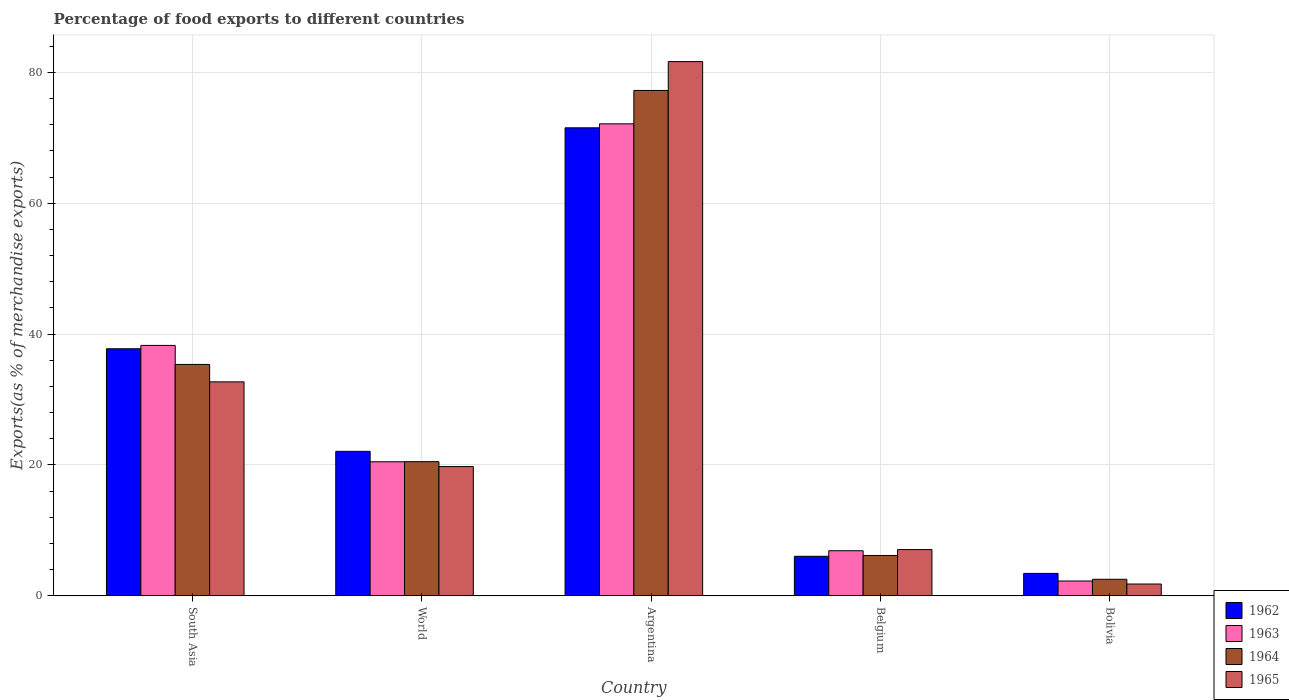How many different coloured bars are there?
Keep it short and to the point. 4. Are the number of bars per tick equal to the number of legend labels?
Ensure brevity in your answer.  Yes. How many bars are there on the 2nd tick from the left?
Your response must be concise. 4. What is the percentage of exports to different countries in 1964 in Argentina?
Your response must be concise. 77.23. Across all countries, what is the maximum percentage of exports to different countries in 1963?
Provide a succinct answer. 72.12. Across all countries, what is the minimum percentage of exports to different countries in 1962?
Your answer should be very brief. 3.43. In which country was the percentage of exports to different countries in 1962 maximum?
Give a very brief answer. Argentina. In which country was the percentage of exports to different countries in 1964 minimum?
Your answer should be very brief. Bolivia. What is the total percentage of exports to different countries in 1964 in the graph?
Ensure brevity in your answer.  141.79. What is the difference between the percentage of exports to different countries in 1962 in Argentina and that in South Asia?
Provide a short and direct response. 33.76. What is the difference between the percentage of exports to different countries in 1965 in Bolivia and the percentage of exports to different countries in 1963 in South Asia?
Ensure brevity in your answer.  -36.46. What is the average percentage of exports to different countries in 1964 per country?
Provide a short and direct response. 28.36. What is the difference between the percentage of exports to different countries of/in 1965 and percentage of exports to different countries of/in 1962 in Argentina?
Ensure brevity in your answer.  10.12. In how many countries, is the percentage of exports to different countries in 1965 greater than 52 %?
Your answer should be compact. 1. What is the ratio of the percentage of exports to different countries in 1964 in Argentina to that in South Asia?
Provide a short and direct response. 2.18. Is the percentage of exports to different countries in 1965 in Belgium less than that in Bolivia?
Make the answer very short. No. Is the difference between the percentage of exports to different countries in 1965 in Belgium and Bolivia greater than the difference between the percentage of exports to different countries in 1962 in Belgium and Bolivia?
Make the answer very short. Yes. What is the difference between the highest and the second highest percentage of exports to different countries in 1962?
Your answer should be very brief. 15.67. What is the difference between the highest and the lowest percentage of exports to different countries in 1965?
Offer a terse response. 79.83. In how many countries, is the percentage of exports to different countries in 1963 greater than the average percentage of exports to different countries in 1963 taken over all countries?
Provide a succinct answer. 2. What does the 4th bar from the left in South Asia represents?
Offer a very short reply. 1965. What does the 1st bar from the right in Argentina represents?
Ensure brevity in your answer.  1965. Is it the case that in every country, the sum of the percentage of exports to different countries in 1963 and percentage of exports to different countries in 1962 is greater than the percentage of exports to different countries in 1964?
Offer a terse response. Yes. What is the difference between two consecutive major ticks on the Y-axis?
Give a very brief answer. 20. Does the graph contain any zero values?
Your answer should be very brief. No. Does the graph contain grids?
Give a very brief answer. Yes. How many legend labels are there?
Your answer should be compact. 4. What is the title of the graph?
Give a very brief answer. Percentage of food exports to different countries. What is the label or title of the Y-axis?
Your answer should be very brief. Exports(as % of merchandise exports). What is the Exports(as % of merchandise exports) of 1962 in South Asia?
Give a very brief answer. 37.75. What is the Exports(as % of merchandise exports) of 1963 in South Asia?
Offer a very short reply. 38.26. What is the Exports(as % of merchandise exports) in 1964 in South Asia?
Your answer should be very brief. 35.36. What is the Exports(as % of merchandise exports) of 1965 in South Asia?
Keep it short and to the point. 32.7. What is the Exports(as % of merchandise exports) in 1962 in World?
Give a very brief answer. 22.08. What is the Exports(as % of merchandise exports) of 1963 in World?
Make the answer very short. 20.49. What is the Exports(as % of merchandise exports) of 1964 in World?
Offer a terse response. 20.5. What is the Exports(as % of merchandise exports) of 1965 in World?
Provide a short and direct response. 19.75. What is the Exports(as % of merchandise exports) of 1962 in Argentina?
Give a very brief answer. 71.52. What is the Exports(as % of merchandise exports) in 1963 in Argentina?
Provide a succinct answer. 72.12. What is the Exports(as % of merchandise exports) of 1964 in Argentina?
Your response must be concise. 77.23. What is the Exports(as % of merchandise exports) of 1965 in Argentina?
Your answer should be compact. 81.64. What is the Exports(as % of merchandise exports) of 1962 in Belgium?
Offer a terse response. 6.04. What is the Exports(as % of merchandise exports) of 1963 in Belgium?
Give a very brief answer. 6.89. What is the Exports(as % of merchandise exports) in 1964 in Belgium?
Provide a short and direct response. 6.17. What is the Exports(as % of merchandise exports) in 1965 in Belgium?
Ensure brevity in your answer.  7.07. What is the Exports(as % of merchandise exports) of 1962 in Bolivia?
Keep it short and to the point. 3.43. What is the Exports(as % of merchandise exports) of 1963 in Bolivia?
Offer a terse response. 2.27. What is the Exports(as % of merchandise exports) of 1964 in Bolivia?
Make the answer very short. 2.53. What is the Exports(as % of merchandise exports) in 1965 in Bolivia?
Provide a short and direct response. 1.81. Across all countries, what is the maximum Exports(as % of merchandise exports) in 1962?
Your answer should be compact. 71.52. Across all countries, what is the maximum Exports(as % of merchandise exports) in 1963?
Provide a short and direct response. 72.12. Across all countries, what is the maximum Exports(as % of merchandise exports) of 1964?
Keep it short and to the point. 77.23. Across all countries, what is the maximum Exports(as % of merchandise exports) of 1965?
Ensure brevity in your answer.  81.64. Across all countries, what is the minimum Exports(as % of merchandise exports) of 1962?
Offer a very short reply. 3.43. Across all countries, what is the minimum Exports(as % of merchandise exports) of 1963?
Make the answer very short. 2.27. Across all countries, what is the minimum Exports(as % of merchandise exports) of 1964?
Provide a short and direct response. 2.53. Across all countries, what is the minimum Exports(as % of merchandise exports) in 1965?
Ensure brevity in your answer.  1.81. What is the total Exports(as % of merchandise exports) of 1962 in the graph?
Your response must be concise. 140.82. What is the total Exports(as % of merchandise exports) in 1963 in the graph?
Your answer should be compact. 140.03. What is the total Exports(as % of merchandise exports) in 1964 in the graph?
Make the answer very short. 141.79. What is the total Exports(as % of merchandise exports) in 1965 in the graph?
Make the answer very short. 142.96. What is the difference between the Exports(as % of merchandise exports) of 1962 in South Asia and that in World?
Provide a short and direct response. 15.67. What is the difference between the Exports(as % of merchandise exports) in 1963 in South Asia and that in World?
Give a very brief answer. 17.78. What is the difference between the Exports(as % of merchandise exports) of 1964 in South Asia and that in World?
Offer a very short reply. 14.86. What is the difference between the Exports(as % of merchandise exports) of 1965 in South Asia and that in World?
Offer a very short reply. 12.95. What is the difference between the Exports(as % of merchandise exports) of 1962 in South Asia and that in Argentina?
Provide a succinct answer. -33.76. What is the difference between the Exports(as % of merchandise exports) in 1963 in South Asia and that in Argentina?
Your answer should be compact. -33.86. What is the difference between the Exports(as % of merchandise exports) in 1964 in South Asia and that in Argentina?
Your response must be concise. -41.87. What is the difference between the Exports(as % of merchandise exports) of 1965 in South Asia and that in Argentina?
Give a very brief answer. -48.94. What is the difference between the Exports(as % of merchandise exports) of 1962 in South Asia and that in Belgium?
Give a very brief answer. 31.71. What is the difference between the Exports(as % of merchandise exports) of 1963 in South Asia and that in Belgium?
Keep it short and to the point. 31.37. What is the difference between the Exports(as % of merchandise exports) in 1964 in South Asia and that in Belgium?
Provide a short and direct response. 29.19. What is the difference between the Exports(as % of merchandise exports) of 1965 in South Asia and that in Belgium?
Keep it short and to the point. 25.62. What is the difference between the Exports(as % of merchandise exports) of 1962 in South Asia and that in Bolivia?
Ensure brevity in your answer.  34.32. What is the difference between the Exports(as % of merchandise exports) of 1963 in South Asia and that in Bolivia?
Offer a very short reply. 36. What is the difference between the Exports(as % of merchandise exports) of 1964 in South Asia and that in Bolivia?
Give a very brief answer. 32.83. What is the difference between the Exports(as % of merchandise exports) in 1965 in South Asia and that in Bolivia?
Keep it short and to the point. 30.89. What is the difference between the Exports(as % of merchandise exports) of 1962 in World and that in Argentina?
Your answer should be compact. -49.44. What is the difference between the Exports(as % of merchandise exports) of 1963 in World and that in Argentina?
Give a very brief answer. -51.64. What is the difference between the Exports(as % of merchandise exports) in 1964 in World and that in Argentina?
Make the answer very short. -56.72. What is the difference between the Exports(as % of merchandise exports) in 1965 in World and that in Argentina?
Give a very brief answer. -61.88. What is the difference between the Exports(as % of merchandise exports) in 1962 in World and that in Belgium?
Offer a terse response. 16.04. What is the difference between the Exports(as % of merchandise exports) in 1963 in World and that in Belgium?
Provide a short and direct response. 13.6. What is the difference between the Exports(as % of merchandise exports) of 1964 in World and that in Belgium?
Provide a short and direct response. 14.33. What is the difference between the Exports(as % of merchandise exports) in 1965 in World and that in Belgium?
Keep it short and to the point. 12.68. What is the difference between the Exports(as % of merchandise exports) in 1962 in World and that in Bolivia?
Your answer should be very brief. 18.65. What is the difference between the Exports(as % of merchandise exports) in 1963 in World and that in Bolivia?
Provide a succinct answer. 18.22. What is the difference between the Exports(as % of merchandise exports) in 1964 in World and that in Bolivia?
Offer a terse response. 17.97. What is the difference between the Exports(as % of merchandise exports) of 1965 in World and that in Bolivia?
Provide a succinct answer. 17.94. What is the difference between the Exports(as % of merchandise exports) of 1962 in Argentina and that in Belgium?
Your answer should be compact. 65.47. What is the difference between the Exports(as % of merchandise exports) of 1963 in Argentina and that in Belgium?
Provide a short and direct response. 65.23. What is the difference between the Exports(as % of merchandise exports) in 1964 in Argentina and that in Belgium?
Provide a short and direct response. 71.06. What is the difference between the Exports(as % of merchandise exports) of 1965 in Argentina and that in Belgium?
Keep it short and to the point. 74.56. What is the difference between the Exports(as % of merchandise exports) of 1962 in Argentina and that in Bolivia?
Provide a short and direct response. 68.09. What is the difference between the Exports(as % of merchandise exports) in 1963 in Argentina and that in Bolivia?
Make the answer very short. 69.86. What is the difference between the Exports(as % of merchandise exports) in 1964 in Argentina and that in Bolivia?
Keep it short and to the point. 74.69. What is the difference between the Exports(as % of merchandise exports) of 1965 in Argentina and that in Bolivia?
Provide a short and direct response. 79.83. What is the difference between the Exports(as % of merchandise exports) of 1962 in Belgium and that in Bolivia?
Your answer should be compact. 2.61. What is the difference between the Exports(as % of merchandise exports) in 1963 in Belgium and that in Bolivia?
Make the answer very short. 4.62. What is the difference between the Exports(as % of merchandise exports) in 1964 in Belgium and that in Bolivia?
Your response must be concise. 3.64. What is the difference between the Exports(as % of merchandise exports) of 1965 in Belgium and that in Bolivia?
Ensure brevity in your answer.  5.27. What is the difference between the Exports(as % of merchandise exports) in 1962 in South Asia and the Exports(as % of merchandise exports) in 1963 in World?
Your answer should be compact. 17.27. What is the difference between the Exports(as % of merchandise exports) of 1962 in South Asia and the Exports(as % of merchandise exports) of 1964 in World?
Your answer should be very brief. 17.25. What is the difference between the Exports(as % of merchandise exports) in 1962 in South Asia and the Exports(as % of merchandise exports) in 1965 in World?
Your answer should be compact. 18. What is the difference between the Exports(as % of merchandise exports) of 1963 in South Asia and the Exports(as % of merchandise exports) of 1964 in World?
Keep it short and to the point. 17.76. What is the difference between the Exports(as % of merchandise exports) in 1963 in South Asia and the Exports(as % of merchandise exports) in 1965 in World?
Offer a very short reply. 18.51. What is the difference between the Exports(as % of merchandise exports) in 1964 in South Asia and the Exports(as % of merchandise exports) in 1965 in World?
Give a very brief answer. 15.61. What is the difference between the Exports(as % of merchandise exports) in 1962 in South Asia and the Exports(as % of merchandise exports) in 1963 in Argentina?
Give a very brief answer. -34.37. What is the difference between the Exports(as % of merchandise exports) in 1962 in South Asia and the Exports(as % of merchandise exports) in 1964 in Argentina?
Your response must be concise. -39.47. What is the difference between the Exports(as % of merchandise exports) in 1962 in South Asia and the Exports(as % of merchandise exports) in 1965 in Argentina?
Offer a very short reply. -43.88. What is the difference between the Exports(as % of merchandise exports) in 1963 in South Asia and the Exports(as % of merchandise exports) in 1964 in Argentina?
Give a very brief answer. -38.96. What is the difference between the Exports(as % of merchandise exports) of 1963 in South Asia and the Exports(as % of merchandise exports) of 1965 in Argentina?
Provide a short and direct response. -43.37. What is the difference between the Exports(as % of merchandise exports) in 1964 in South Asia and the Exports(as % of merchandise exports) in 1965 in Argentina?
Your answer should be compact. -46.28. What is the difference between the Exports(as % of merchandise exports) in 1962 in South Asia and the Exports(as % of merchandise exports) in 1963 in Belgium?
Make the answer very short. 30.86. What is the difference between the Exports(as % of merchandise exports) in 1962 in South Asia and the Exports(as % of merchandise exports) in 1964 in Belgium?
Your response must be concise. 31.58. What is the difference between the Exports(as % of merchandise exports) of 1962 in South Asia and the Exports(as % of merchandise exports) of 1965 in Belgium?
Offer a terse response. 30.68. What is the difference between the Exports(as % of merchandise exports) of 1963 in South Asia and the Exports(as % of merchandise exports) of 1964 in Belgium?
Your answer should be compact. 32.09. What is the difference between the Exports(as % of merchandise exports) of 1963 in South Asia and the Exports(as % of merchandise exports) of 1965 in Belgium?
Your response must be concise. 31.19. What is the difference between the Exports(as % of merchandise exports) of 1964 in South Asia and the Exports(as % of merchandise exports) of 1965 in Belgium?
Ensure brevity in your answer.  28.29. What is the difference between the Exports(as % of merchandise exports) in 1962 in South Asia and the Exports(as % of merchandise exports) in 1963 in Bolivia?
Give a very brief answer. 35.49. What is the difference between the Exports(as % of merchandise exports) of 1962 in South Asia and the Exports(as % of merchandise exports) of 1964 in Bolivia?
Provide a short and direct response. 35.22. What is the difference between the Exports(as % of merchandise exports) of 1962 in South Asia and the Exports(as % of merchandise exports) of 1965 in Bolivia?
Your answer should be compact. 35.95. What is the difference between the Exports(as % of merchandise exports) of 1963 in South Asia and the Exports(as % of merchandise exports) of 1964 in Bolivia?
Ensure brevity in your answer.  35.73. What is the difference between the Exports(as % of merchandise exports) of 1963 in South Asia and the Exports(as % of merchandise exports) of 1965 in Bolivia?
Provide a short and direct response. 36.46. What is the difference between the Exports(as % of merchandise exports) of 1964 in South Asia and the Exports(as % of merchandise exports) of 1965 in Bolivia?
Provide a succinct answer. 33.55. What is the difference between the Exports(as % of merchandise exports) in 1962 in World and the Exports(as % of merchandise exports) in 1963 in Argentina?
Provide a succinct answer. -50.04. What is the difference between the Exports(as % of merchandise exports) of 1962 in World and the Exports(as % of merchandise exports) of 1964 in Argentina?
Your answer should be compact. -55.15. What is the difference between the Exports(as % of merchandise exports) of 1962 in World and the Exports(as % of merchandise exports) of 1965 in Argentina?
Your answer should be compact. -59.55. What is the difference between the Exports(as % of merchandise exports) of 1963 in World and the Exports(as % of merchandise exports) of 1964 in Argentina?
Keep it short and to the point. -56.74. What is the difference between the Exports(as % of merchandise exports) of 1963 in World and the Exports(as % of merchandise exports) of 1965 in Argentina?
Provide a short and direct response. -61.15. What is the difference between the Exports(as % of merchandise exports) of 1964 in World and the Exports(as % of merchandise exports) of 1965 in Argentina?
Make the answer very short. -61.13. What is the difference between the Exports(as % of merchandise exports) in 1962 in World and the Exports(as % of merchandise exports) in 1963 in Belgium?
Keep it short and to the point. 15.19. What is the difference between the Exports(as % of merchandise exports) of 1962 in World and the Exports(as % of merchandise exports) of 1964 in Belgium?
Give a very brief answer. 15.91. What is the difference between the Exports(as % of merchandise exports) of 1962 in World and the Exports(as % of merchandise exports) of 1965 in Belgium?
Ensure brevity in your answer.  15.01. What is the difference between the Exports(as % of merchandise exports) of 1963 in World and the Exports(as % of merchandise exports) of 1964 in Belgium?
Provide a succinct answer. 14.32. What is the difference between the Exports(as % of merchandise exports) of 1963 in World and the Exports(as % of merchandise exports) of 1965 in Belgium?
Keep it short and to the point. 13.41. What is the difference between the Exports(as % of merchandise exports) in 1964 in World and the Exports(as % of merchandise exports) in 1965 in Belgium?
Give a very brief answer. 13.43. What is the difference between the Exports(as % of merchandise exports) in 1962 in World and the Exports(as % of merchandise exports) in 1963 in Bolivia?
Keep it short and to the point. 19.81. What is the difference between the Exports(as % of merchandise exports) in 1962 in World and the Exports(as % of merchandise exports) in 1964 in Bolivia?
Provide a succinct answer. 19.55. What is the difference between the Exports(as % of merchandise exports) in 1962 in World and the Exports(as % of merchandise exports) in 1965 in Bolivia?
Make the answer very short. 20.27. What is the difference between the Exports(as % of merchandise exports) in 1963 in World and the Exports(as % of merchandise exports) in 1964 in Bolivia?
Your response must be concise. 17.95. What is the difference between the Exports(as % of merchandise exports) of 1963 in World and the Exports(as % of merchandise exports) of 1965 in Bolivia?
Provide a succinct answer. 18.68. What is the difference between the Exports(as % of merchandise exports) in 1964 in World and the Exports(as % of merchandise exports) in 1965 in Bolivia?
Your response must be concise. 18.7. What is the difference between the Exports(as % of merchandise exports) of 1962 in Argentina and the Exports(as % of merchandise exports) of 1963 in Belgium?
Ensure brevity in your answer.  64.63. What is the difference between the Exports(as % of merchandise exports) in 1962 in Argentina and the Exports(as % of merchandise exports) in 1964 in Belgium?
Give a very brief answer. 65.35. What is the difference between the Exports(as % of merchandise exports) in 1962 in Argentina and the Exports(as % of merchandise exports) in 1965 in Belgium?
Offer a very short reply. 64.44. What is the difference between the Exports(as % of merchandise exports) of 1963 in Argentina and the Exports(as % of merchandise exports) of 1964 in Belgium?
Give a very brief answer. 65.95. What is the difference between the Exports(as % of merchandise exports) in 1963 in Argentina and the Exports(as % of merchandise exports) in 1965 in Belgium?
Give a very brief answer. 65.05. What is the difference between the Exports(as % of merchandise exports) in 1964 in Argentina and the Exports(as % of merchandise exports) in 1965 in Belgium?
Offer a very short reply. 70.15. What is the difference between the Exports(as % of merchandise exports) of 1962 in Argentina and the Exports(as % of merchandise exports) of 1963 in Bolivia?
Provide a short and direct response. 69.25. What is the difference between the Exports(as % of merchandise exports) in 1962 in Argentina and the Exports(as % of merchandise exports) in 1964 in Bolivia?
Your answer should be very brief. 68.98. What is the difference between the Exports(as % of merchandise exports) of 1962 in Argentina and the Exports(as % of merchandise exports) of 1965 in Bolivia?
Offer a terse response. 69.71. What is the difference between the Exports(as % of merchandise exports) of 1963 in Argentina and the Exports(as % of merchandise exports) of 1964 in Bolivia?
Ensure brevity in your answer.  69.59. What is the difference between the Exports(as % of merchandise exports) of 1963 in Argentina and the Exports(as % of merchandise exports) of 1965 in Bolivia?
Provide a short and direct response. 70.32. What is the difference between the Exports(as % of merchandise exports) of 1964 in Argentina and the Exports(as % of merchandise exports) of 1965 in Bolivia?
Your response must be concise. 75.42. What is the difference between the Exports(as % of merchandise exports) of 1962 in Belgium and the Exports(as % of merchandise exports) of 1963 in Bolivia?
Your response must be concise. 3.78. What is the difference between the Exports(as % of merchandise exports) of 1962 in Belgium and the Exports(as % of merchandise exports) of 1964 in Bolivia?
Ensure brevity in your answer.  3.51. What is the difference between the Exports(as % of merchandise exports) of 1962 in Belgium and the Exports(as % of merchandise exports) of 1965 in Bolivia?
Offer a very short reply. 4.24. What is the difference between the Exports(as % of merchandise exports) of 1963 in Belgium and the Exports(as % of merchandise exports) of 1964 in Bolivia?
Provide a succinct answer. 4.36. What is the difference between the Exports(as % of merchandise exports) of 1963 in Belgium and the Exports(as % of merchandise exports) of 1965 in Bolivia?
Your answer should be compact. 5.08. What is the difference between the Exports(as % of merchandise exports) in 1964 in Belgium and the Exports(as % of merchandise exports) in 1965 in Bolivia?
Make the answer very short. 4.36. What is the average Exports(as % of merchandise exports) of 1962 per country?
Your response must be concise. 28.16. What is the average Exports(as % of merchandise exports) in 1963 per country?
Your answer should be compact. 28.01. What is the average Exports(as % of merchandise exports) in 1964 per country?
Ensure brevity in your answer.  28.36. What is the average Exports(as % of merchandise exports) in 1965 per country?
Offer a terse response. 28.59. What is the difference between the Exports(as % of merchandise exports) in 1962 and Exports(as % of merchandise exports) in 1963 in South Asia?
Provide a succinct answer. -0.51. What is the difference between the Exports(as % of merchandise exports) of 1962 and Exports(as % of merchandise exports) of 1964 in South Asia?
Your answer should be compact. 2.39. What is the difference between the Exports(as % of merchandise exports) in 1962 and Exports(as % of merchandise exports) in 1965 in South Asia?
Offer a terse response. 5.06. What is the difference between the Exports(as % of merchandise exports) of 1963 and Exports(as % of merchandise exports) of 1964 in South Asia?
Provide a short and direct response. 2.9. What is the difference between the Exports(as % of merchandise exports) in 1963 and Exports(as % of merchandise exports) in 1965 in South Asia?
Your answer should be compact. 5.57. What is the difference between the Exports(as % of merchandise exports) of 1964 and Exports(as % of merchandise exports) of 1965 in South Asia?
Ensure brevity in your answer.  2.66. What is the difference between the Exports(as % of merchandise exports) in 1962 and Exports(as % of merchandise exports) in 1963 in World?
Keep it short and to the point. 1.59. What is the difference between the Exports(as % of merchandise exports) of 1962 and Exports(as % of merchandise exports) of 1964 in World?
Provide a succinct answer. 1.58. What is the difference between the Exports(as % of merchandise exports) in 1962 and Exports(as % of merchandise exports) in 1965 in World?
Your answer should be very brief. 2.33. What is the difference between the Exports(as % of merchandise exports) of 1963 and Exports(as % of merchandise exports) of 1964 in World?
Provide a short and direct response. -0.02. What is the difference between the Exports(as % of merchandise exports) of 1963 and Exports(as % of merchandise exports) of 1965 in World?
Provide a short and direct response. 0.74. What is the difference between the Exports(as % of merchandise exports) of 1964 and Exports(as % of merchandise exports) of 1965 in World?
Provide a short and direct response. 0.75. What is the difference between the Exports(as % of merchandise exports) in 1962 and Exports(as % of merchandise exports) in 1963 in Argentina?
Your answer should be compact. -0.61. What is the difference between the Exports(as % of merchandise exports) of 1962 and Exports(as % of merchandise exports) of 1964 in Argentina?
Provide a short and direct response. -5.71. What is the difference between the Exports(as % of merchandise exports) of 1962 and Exports(as % of merchandise exports) of 1965 in Argentina?
Provide a short and direct response. -10.12. What is the difference between the Exports(as % of merchandise exports) in 1963 and Exports(as % of merchandise exports) in 1964 in Argentina?
Give a very brief answer. -5.1. What is the difference between the Exports(as % of merchandise exports) in 1963 and Exports(as % of merchandise exports) in 1965 in Argentina?
Keep it short and to the point. -9.51. What is the difference between the Exports(as % of merchandise exports) of 1964 and Exports(as % of merchandise exports) of 1965 in Argentina?
Offer a terse response. -4.41. What is the difference between the Exports(as % of merchandise exports) of 1962 and Exports(as % of merchandise exports) of 1963 in Belgium?
Provide a short and direct response. -0.85. What is the difference between the Exports(as % of merchandise exports) in 1962 and Exports(as % of merchandise exports) in 1964 in Belgium?
Offer a terse response. -0.13. What is the difference between the Exports(as % of merchandise exports) of 1962 and Exports(as % of merchandise exports) of 1965 in Belgium?
Offer a terse response. -1.03. What is the difference between the Exports(as % of merchandise exports) in 1963 and Exports(as % of merchandise exports) in 1964 in Belgium?
Keep it short and to the point. 0.72. What is the difference between the Exports(as % of merchandise exports) in 1963 and Exports(as % of merchandise exports) in 1965 in Belgium?
Provide a short and direct response. -0.18. What is the difference between the Exports(as % of merchandise exports) in 1964 and Exports(as % of merchandise exports) in 1965 in Belgium?
Ensure brevity in your answer.  -0.9. What is the difference between the Exports(as % of merchandise exports) of 1962 and Exports(as % of merchandise exports) of 1963 in Bolivia?
Provide a succinct answer. 1.16. What is the difference between the Exports(as % of merchandise exports) of 1962 and Exports(as % of merchandise exports) of 1964 in Bolivia?
Your response must be concise. 0.9. What is the difference between the Exports(as % of merchandise exports) in 1962 and Exports(as % of merchandise exports) in 1965 in Bolivia?
Your response must be concise. 1.62. What is the difference between the Exports(as % of merchandise exports) of 1963 and Exports(as % of merchandise exports) of 1964 in Bolivia?
Offer a terse response. -0.27. What is the difference between the Exports(as % of merchandise exports) in 1963 and Exports(as % of merchandise exports) in 1965 in Bolivia?
Ensure brevity in your answer.  0.46. What is the difference between the Exports(as % of merchandise exports) of 1964 and Exports(as % of merchandise exports) of 1965 in Bolivia?
Provide a short and direct response. 0.73. What is the ratio of the Exports(as % of merchandise exports) of 1962 in South Asia to that in World?
Offer a terse response. 1.71. What is the ratio of the Exports(as % of merchandise exports) of 1963 in South Asia to that in World?
Your response must be concise. 1.87. What is the ratio of the Exports(as % of merchandise exports) of 1964 in South Asia to that in World?
Give a very brief answer. 1.72. What is the ratio of the Exports(as % of merchandise exports) of 1965 in South Asia to that in World?
Your answer should be very brief. 1.66. What is the ratio of the Exports(as % of merchandise exports) of 1962 in South Asia to that in Argentina?
Your answer should be very brief. 0.53. What is the ratio of the Exports(as % of merchandise exports) in 1963 in South Asia to that in Argentina?
Your response must be concise. 0.53. What is the ratio of the Exports(as % of merchandise exports) of 1964 in South Asia to that in Argentina?
Your response must be concise. 0.46. What is the ratio of the Exports(as % of merchandise exports) of 1965 in South Asia to that in Argentina?
Provide a succinct answer. 0.4. What is the ratio of the Exports(as % of merchandise exports) in 1962 in South Asia to that in Belgium?
Give a very brief answer. 6.25. What is the ratio of the Exports(as % of merchandise exports) in 1963 in South Asia to that in Belgium?
Provide a short and direct response. 5.55. What is the ratio of the Exports(as % of merchandise exports) of 1964 in South Asia to that in Belgium?
Your response must be concise. 5.73. What is the ratio of the Exports(as % of merchandise exports) of 1965 in South Asia to that in Belgium?
Your answer should be compact. 4.62. What is the ratio of the Exports(as % of merchandise exports) of 1962 in South Asia to that in Bolivia?
Make the answer very short. 11.01. What is the ratio of the Exports(as % of merchandise exports) of 1963 in South Asia to that in Bolivia?
Ensure brevity in your answer.  16.89. What is the ratio of the Exports(as % of merchandise exports) in 1964 in South Asia to that in Bolivia?
Make the answer very short. 13.97. What is the ratio of the Exports(as % of merchandise exports) of 1965 in South Asia to that in Bolivia?
Offer a terse response. 18.1. What is the ratio of the Exports(as % of merchandise exports) in 1962 in World to that in Argentina?
Ensure brevity in your answer.  0.31. What is the ratio of the Exports(as % of merchandise exports) of 1963 in World to that in Argentina?
Your answer should be compact. 0.28. What is the ratio of the Exports(as % of merchandise exports) in 1964 in World to that in Argentina?
Your answer should be compact. 0.27. What is the ratio of the Exports(as % of merchandise exports) of 1965 in World to that in Argentina?
Offer a very short reply. 0.24. What is the ratio of the Exports(as % of merchandise exports) of 1962 in World to that in Belgium?
Your answer should be very brief. 3.65. What is the ratio of the Exports(as % of merchandise exports) in 1963 in World to that in Belgium?
Your answer should be compact. 2.97. What is the ratio of the Exports(as % of merchandise exports) in 1964 in World to that in Belgium?
Offer a very short reply. 3.32. What is the ratio of the Exports(as % of merchandise exports) of 1965 in World to that in Belgium?
Give a very brief answer. 2.79. What is the ratio of the Exports(as % of merchandise exports) of 1962 in World to that in Bolivia?
Your answer should be very brief. 6.44. What is the ratio of the Exports(as % of merchandise exports) of 1963 in World to that in Bolivia?
Your response must be concise. 9.04. What is the ratio of the Exports(as % of merchandise exports) of 1964 in World to that in Bolivia?
Ensure brevity in your answer.  8.1. What is the ratio of the Exports(as % of merchandise exports) in 1965 in World to that in Bolivia?
Make the answer very short. 10.93. What is the ratio of the Exports(as % of merchandise exports) in 1962 in Argentina to that in Belgium?
Ensure brevity in your answer.  11.84. What is the ratio of the Exports(as % of merchandise exports) in 1963 in Argentina to that in Belgium?
Make the answer very short. 10.47. What is the ratio of the Exports(as % of merchandise exports) in 1964 in Argentina to that in Belgium?
Provide a short and direct response. 12.52. What is the ratio of the Exports(as % of merchandise exports) in 1965 in Argentina to that in Belgium?
Provide a succinct answer. 11.54. What is the ratio of the Exports(as % of merchandise exports) in 1962 in Argentina to that in Bolivia?
Make the answer very short. 20.86. What is the ratio of the Exports(as % of merchandise exports) in 1963 in Argentina to that in Bolivia?
Give a very brief answer. 31.83. What is the ratio of the Exports(as % of merchandise exports) in 1964 in Argentina to that in Bolivia?
Keep it short and to the point. 30.5. What is the ratio of the Exports(as % of merchandise exports) of 1965 in Argentina to that in Bolivia?
Offer a very short reply. 45.18. What is the ratio of the Exports(as % of merchandise exports) in 1962 in Belgium to that in Bolivia?
Your answer should be compact. 1.76. What is the ratio of the Exports(as % of merchandise exports) in 1963 in Belgium to that in Bolivia?
Provide a succinct answer. 3.04. What is the ratio of the Exports(as % of merchandise exports) of 1964 in Belgium to that in Bolivia?
Provide a short and direct response. 2.44. What is the ratio of the Exports(as % of merchandise exports) of 1965 in Belgium to that in Bolivia?
Make the answer very short. 3.91. What is the difference between the highest and the second highest Exports(as % of merchandise exports) of 1962?
Make the answer very short. 33.76. What is the difference between the highest and the second highest Exports(as % of merchandise exports) of 1963?
Provide a succinct answer. 33.86. What is the difference between the highest and the second highest Exports(as % of merchandise exports) of 1964?
Provide a succinct answer. 41.87. What is the difference between the highest and the second highest Exports(as % of merchandise exports) in 1965?
Offer a very short reply. 48.94. What is the difference between the highest and the lowest Exports(as % of merchandise exports) in 1962?
Provide a short and direct response. 68.09. What is the difference between the highest and the lowest Exports(as % of merchandise exports) of 1963?
Keep it short and to the point. 69.86. What is the difference between the highest and the lowest Exports(as % of merchandise exports) in 1964?
Keep it short and to the point. 74.69. What is the difference between the highest and the lowest Exports(as % of merchandise exports) in 1965?
Make the answer very short. 79.83. 